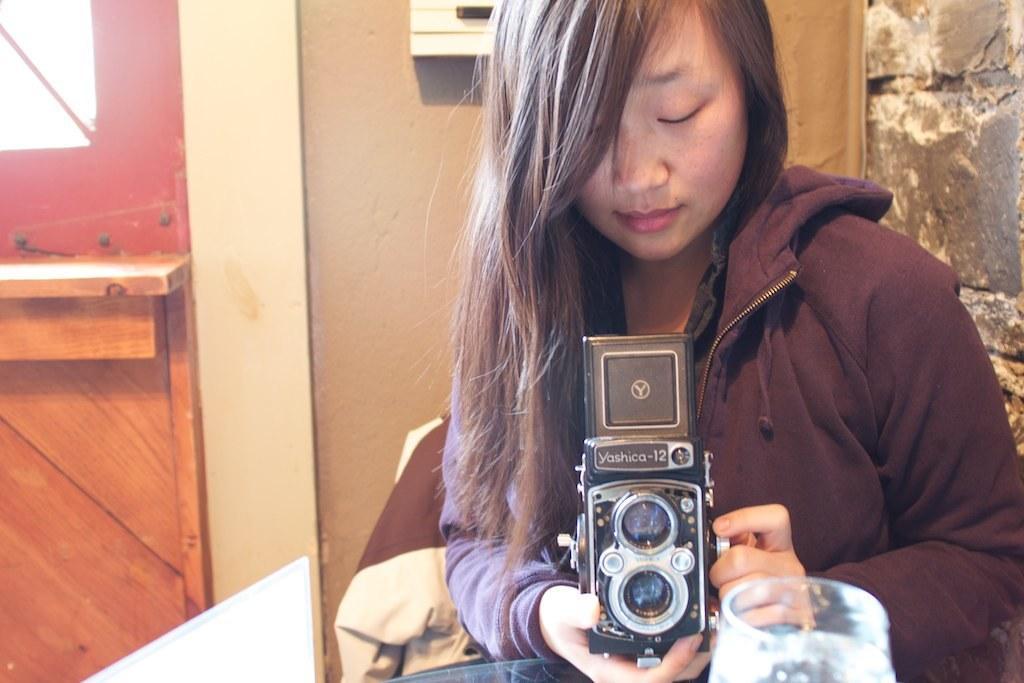Please provide a concise description of this image. This picture is clicked inside the room. Woman in purple t-shirt is sitting on chair and she is holding camera in her hand. In front of her, we see a glass. Behind her, we see a brown wall and beside that, we see a red wall. 